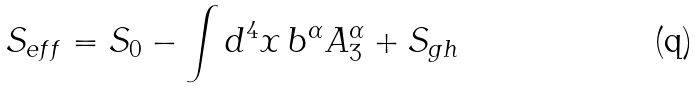Convert formula to latex. <formula><loc_0><loc_0><loc_500><loc_500>S _ { e f f } = S _ { 0 } - \int d ^ { 4 } x \, b ^ { \alpha } A _ { 3 } ^ { \alpha } + S _ { g h }</formula> 